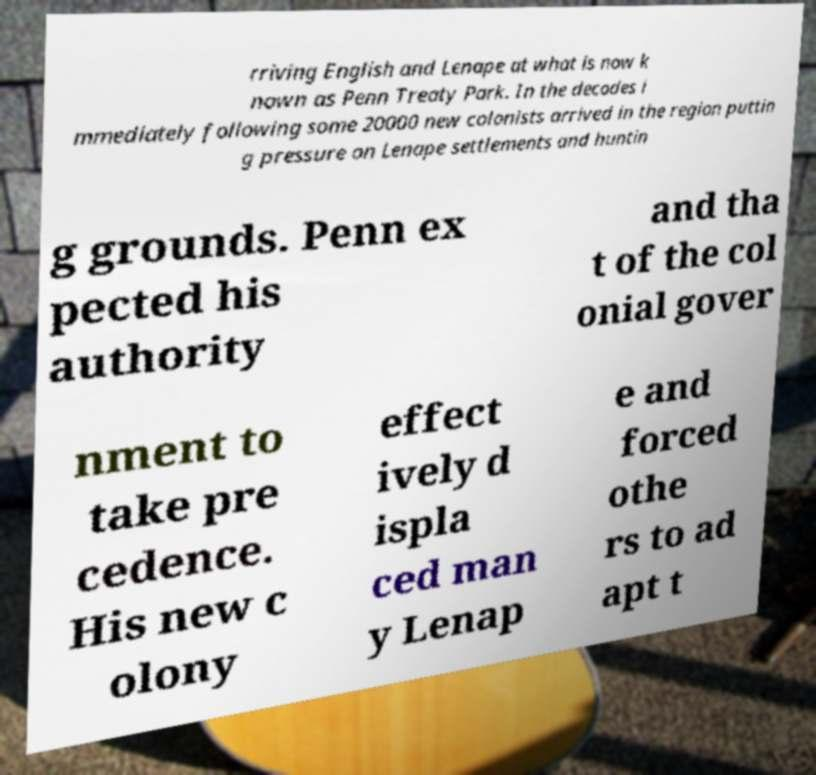Please read and relay the text visible in this image. What does it say? rriving English and Lenape at what is now k nown as Penn Treaty Park. In the decades i mmediately following some 20000 new colonists arrived in the region puttin g pressure on Lenape settlements and huntin g grounds. Penn ex pected his authority and tha t of the col onial gover nment to take pre cedence. His new c olony effect ively d ispla ced man y Lenap e and forced othe rs to ad apt t 